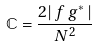<formula> <loc_0><loc_0><loc_500><loc_500>\mathbb { C } = \frac { 2 | \, f \, g ^ { * } \, | } { N ^ { 2 } }</formula> 